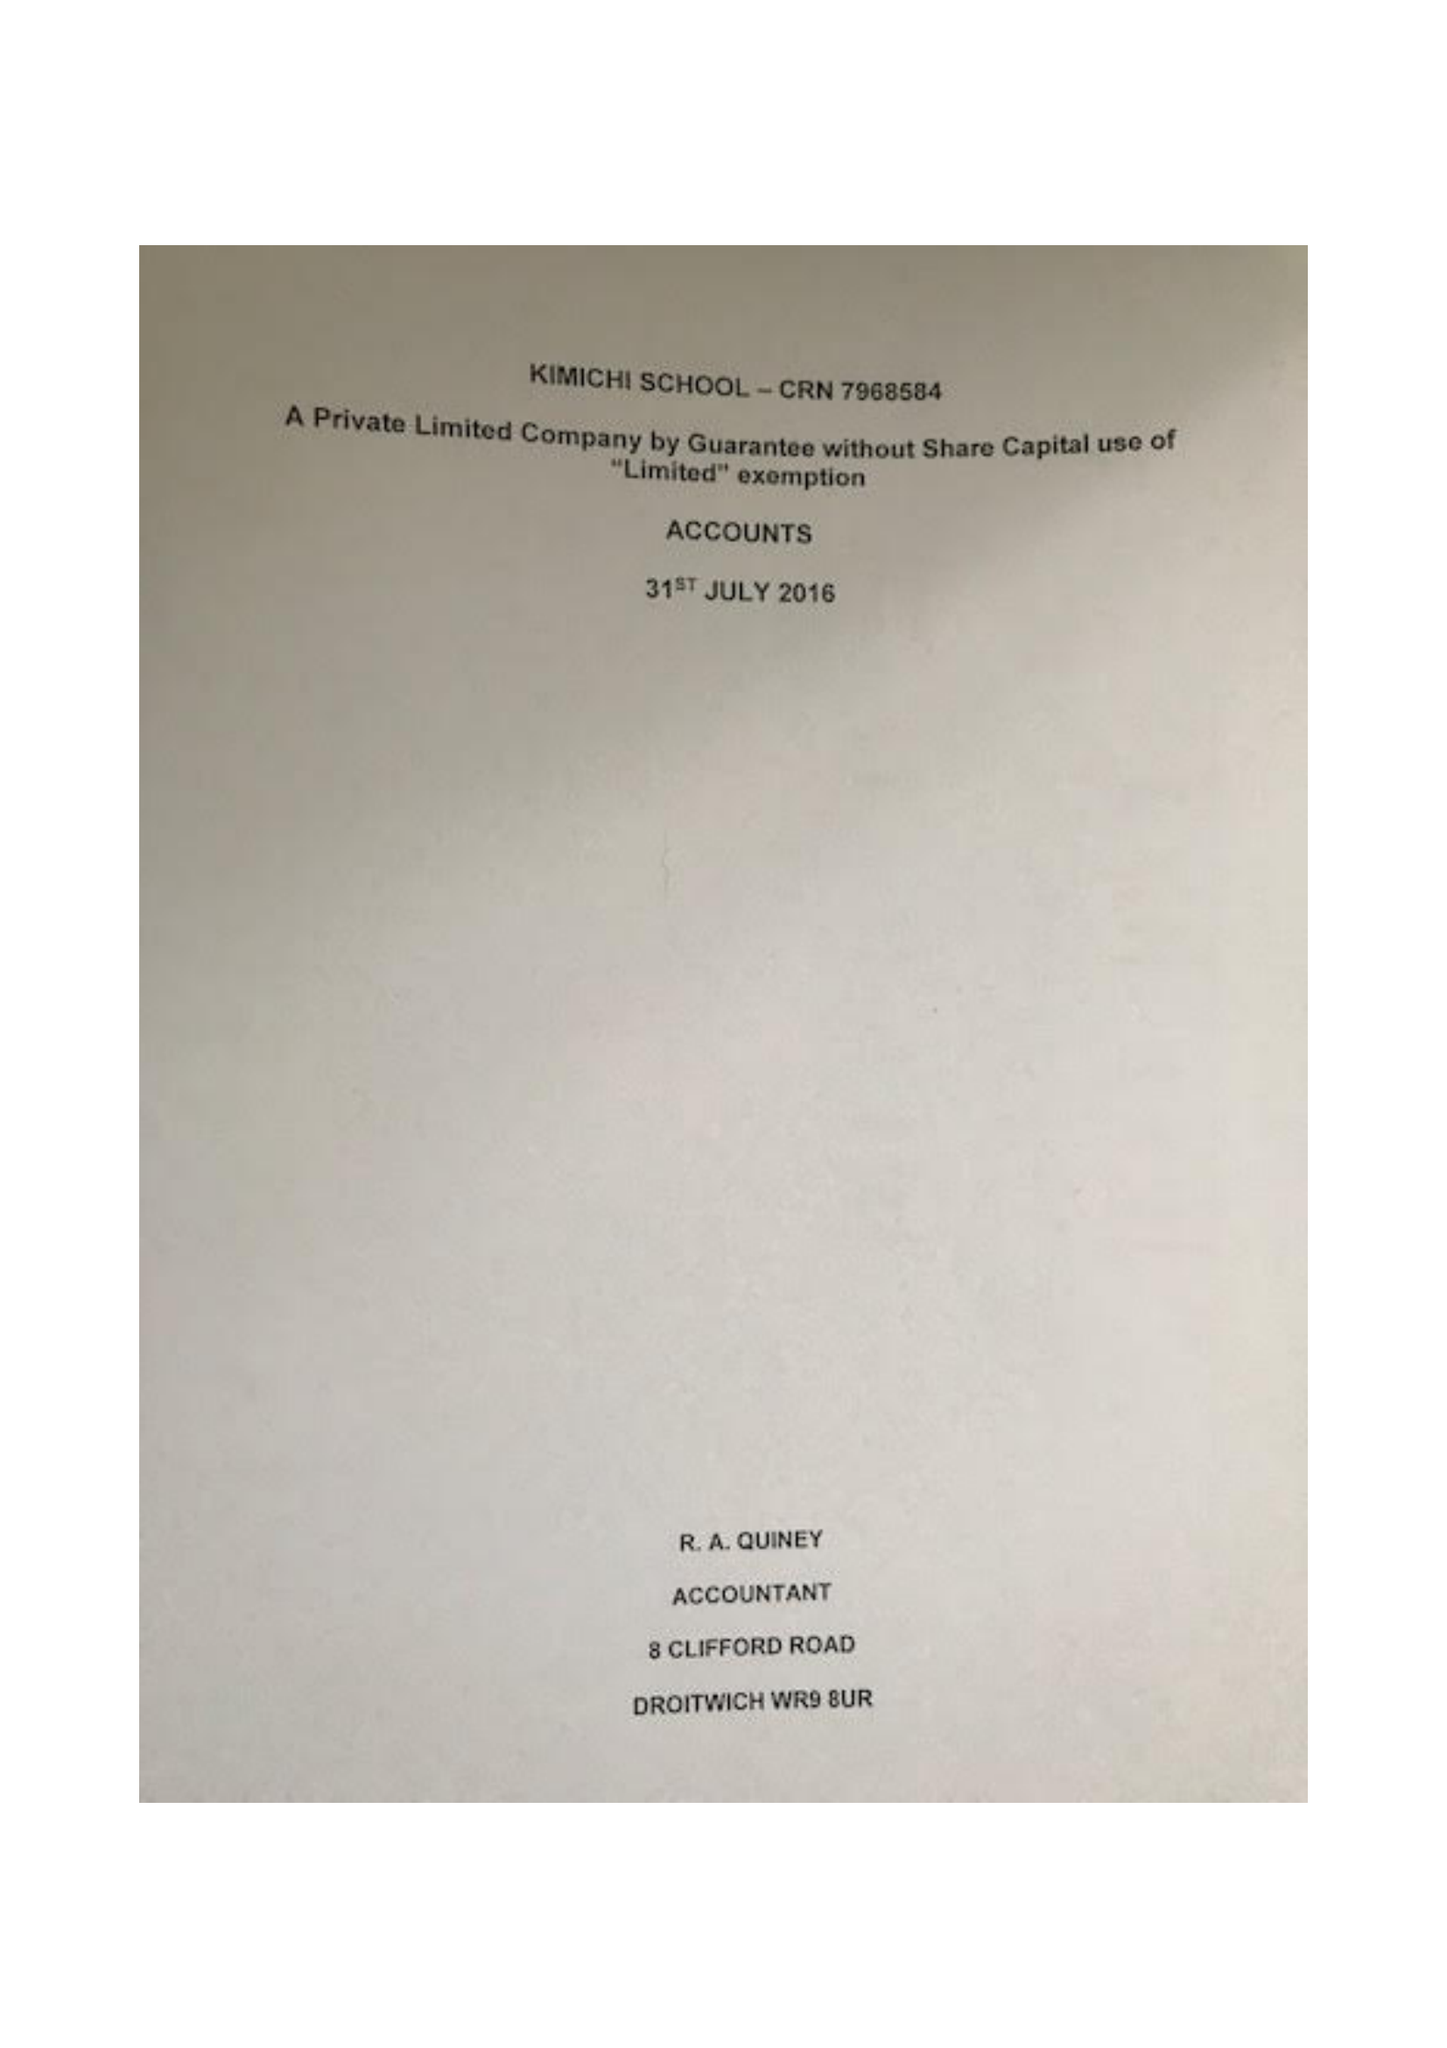What is the value for the charity_number?
Answer the question using a single word or phrase. 1149571 